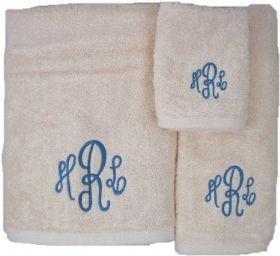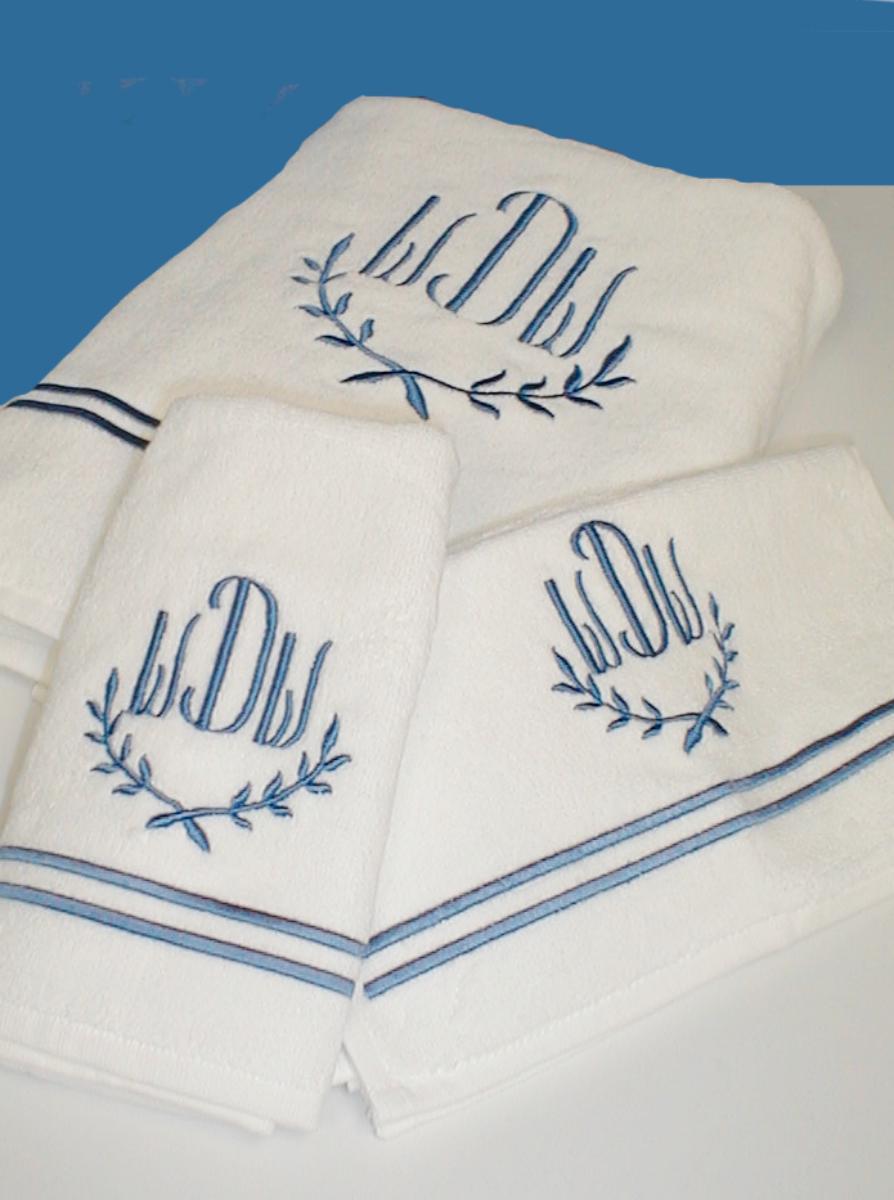The first image is the image on the left, the second image is the image on the right. Considering the images on both sides, is "The middle letter in the monogram on several of the towels is a capital R." valid? Answer yes or no. Yes. 